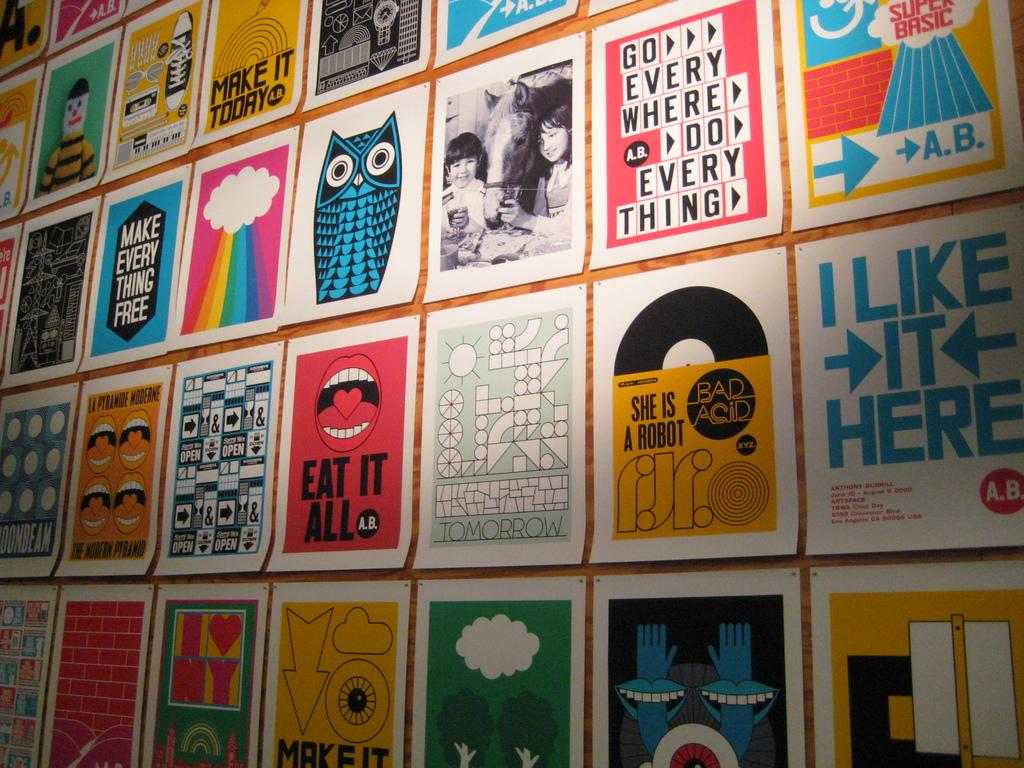<image>
Create a compact narrative representing the image presented. Many posters hang on a wall, one of which says "make everything free". 